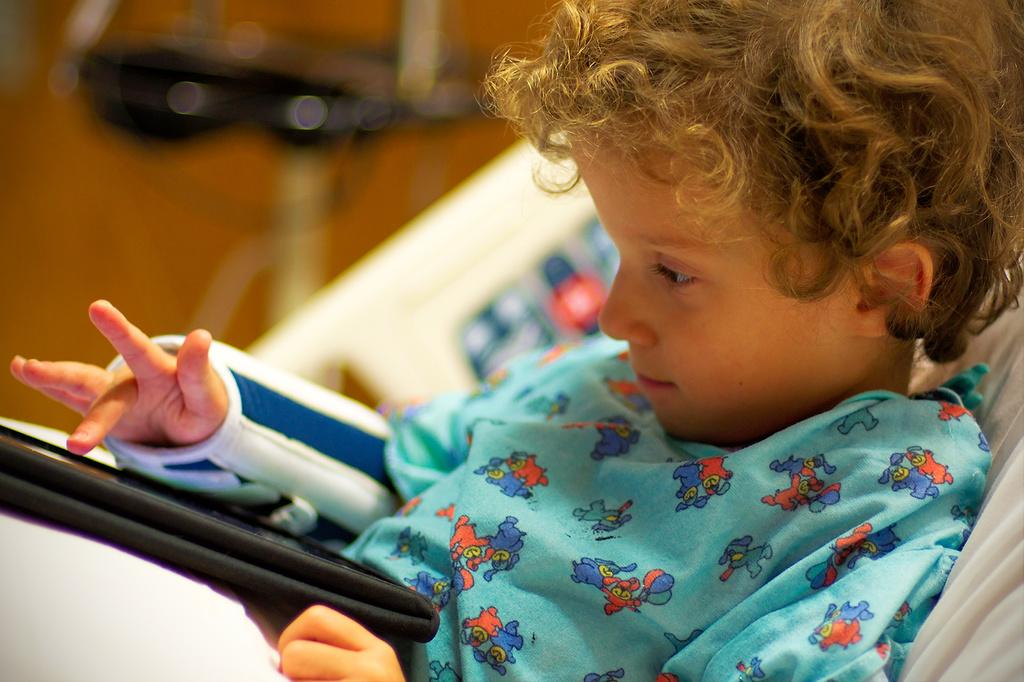What is the main subject of the image? The main subject of the image is a kid. Where is the kid located in the image? The kid is on a bed. What is the kid doing in the image? The kid is using an electronic gadget. Can you describe the background of the image? The background of the image is blurred. What type of zebra can be seen in the wilderness in the image? There is no zebra or wilderness present in the image; it features a kid on a bed using an electronic gadget. 